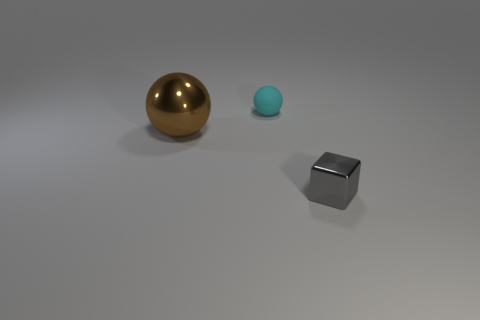Add 3 brown objects. How many objects exist? 6 Add 2 large green metallic cubes. How many large green metallic cubes exist? 2 Subtract 0 blue spheres. How many objects are left? 3 Subtract all blocks. How many objects are left? 2 Subtract all brown balls. Subtract all blue rubber things. How many objects are left? 2 Add 2 large brown spheres. How many large brown spheres are left? 3 